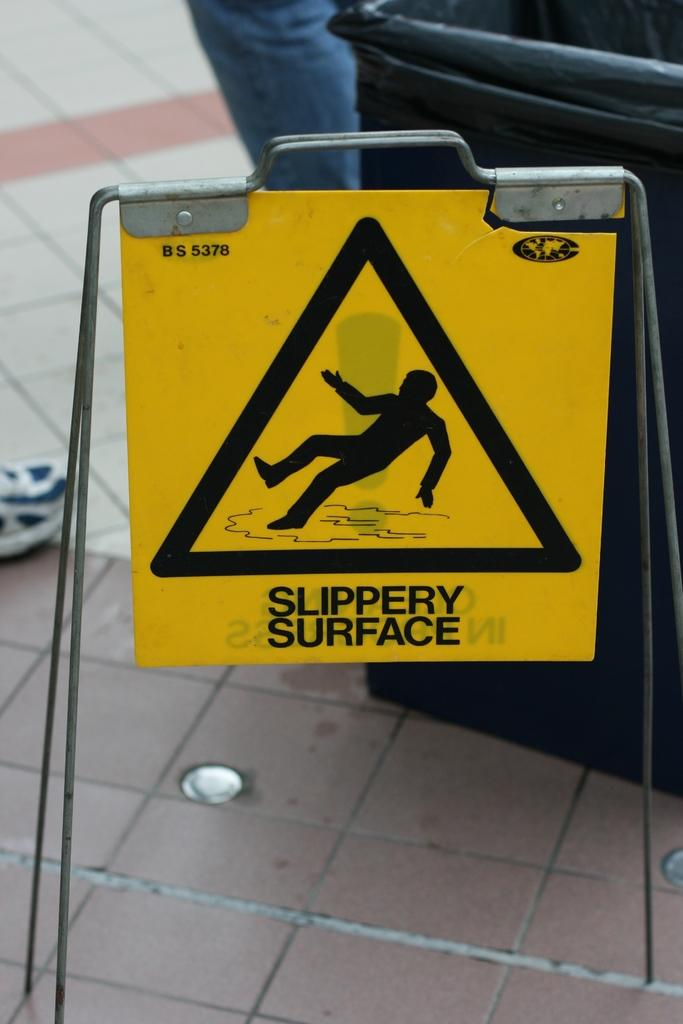<image>
Render a clear and concise summary of the photo. A tile floor with a Slippery Surface sign along it next to a trash can. 